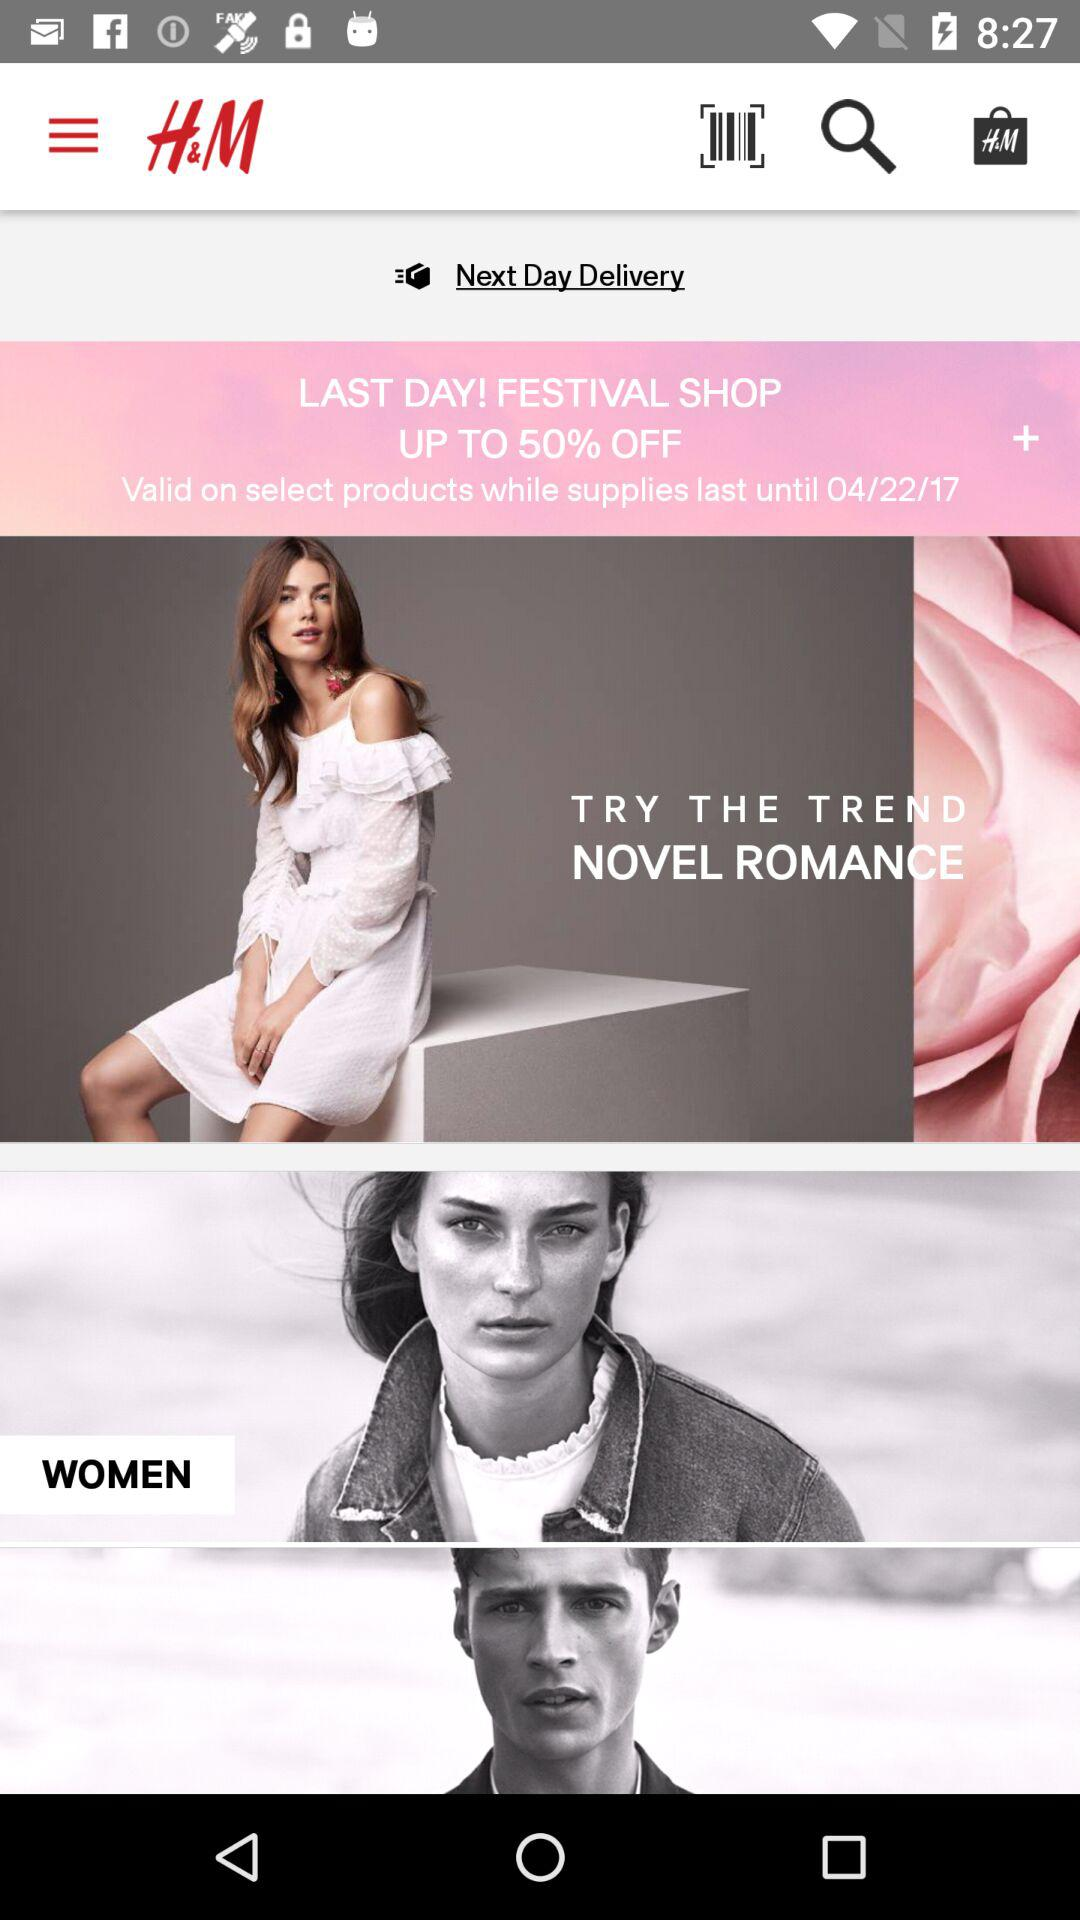How long will it take to deliver? It will be delivered the next day. 